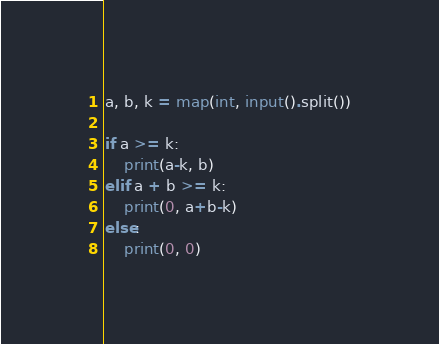<code> <loc_0><loc_0><loc_500><loc_500><_Python_>a, b, k = map(int, input().split())

if a >= k:
    print(a-k, b)
elif a + b >= k:
    print(0, a+b-k)
else:
    print(0, 0)</code> 